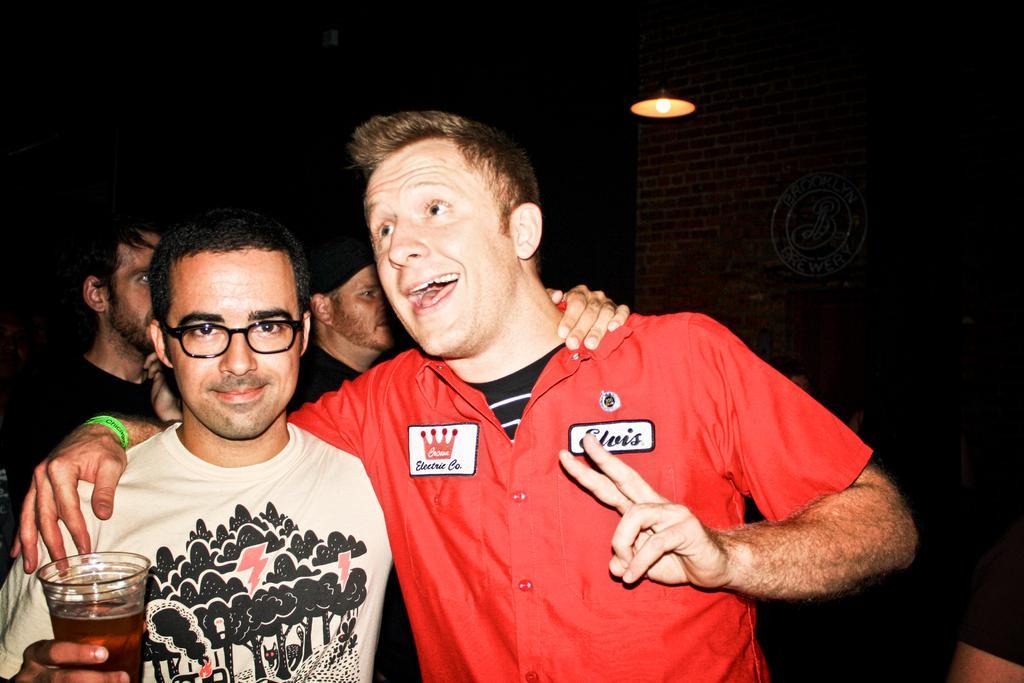In one or two sentences, can you explain what this image depicts? This picture describes about group of people, on the left side of the image we can see a man, he wore spectacles and he is holding a glass, in the background we can see a wall and a light. 